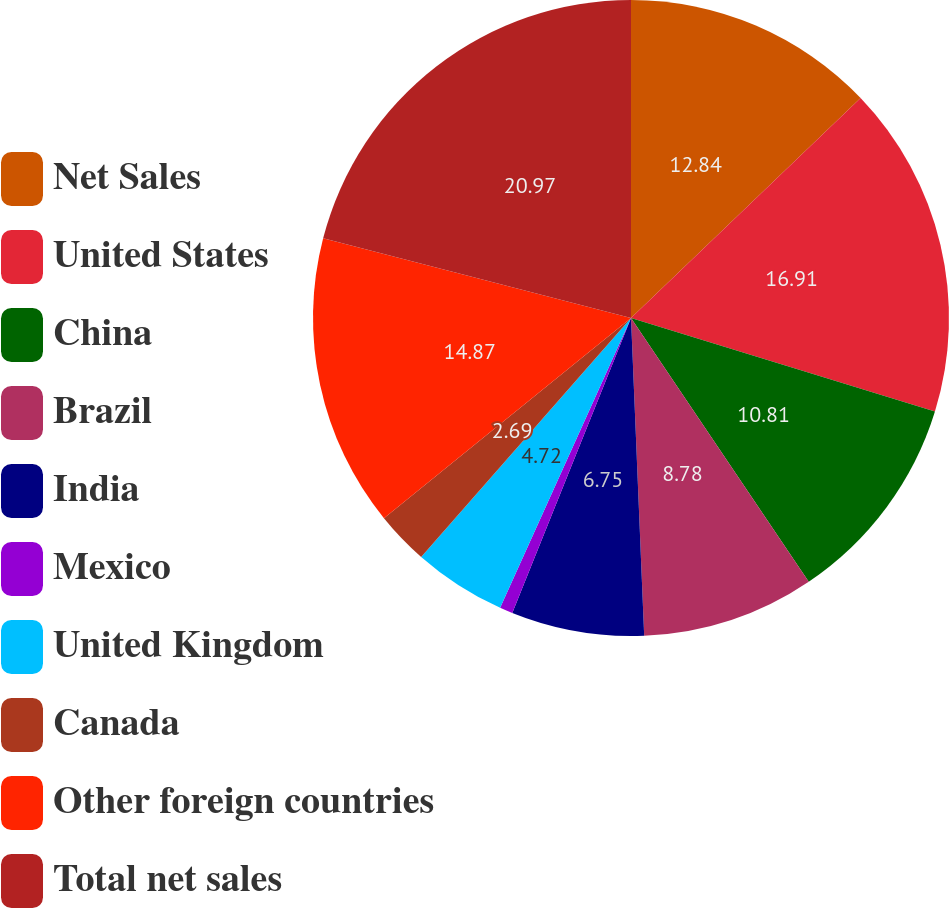Convert chart to OTSL. <chart><loc_0><loc_0><loc_500><loc_500><pie_chart><fcel>Net Sales<fcel>United States<fcel>China<fcel>Brazil<fcel>India<fcel>Mexico<fcel>United Kingdom<fcel>Canada<fcel>Other foreign countries<fcel>Total net sales<nl><fcel>12.84%<fcel>16.91%<fcel>10.81%<fcel>8.78%<fcel>6.75%<fcel>0.66%<fcel>4.72%<fcel>2.69%<fcel>14.87%<fcel>20.97%<nl></chart> 